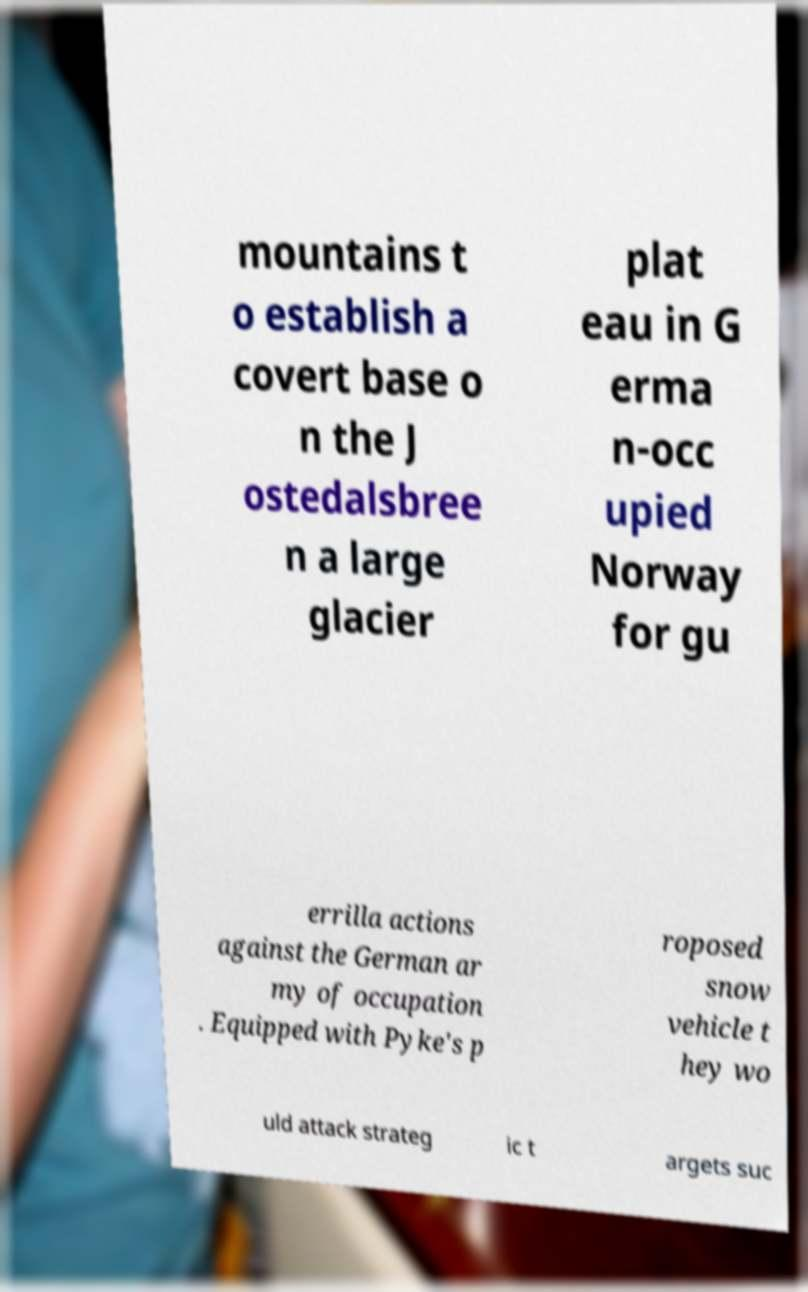Could you assist in decoding the text presented in this image and type it out clearly? mountains t o establish a covert base o n the J ostedalsbree n a large glacier plat eau in G erma n-occ upied Norway for gu errilla actions against the German ar my of occupation . Equipped with Pyke's p roposed snow vehicle t hey wo uld attack strateg ic t argets suc 